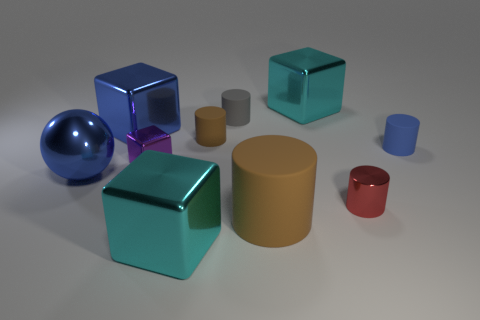Subtract 1 cylinders. How many cylinders are left? 4 Subtract all gray cylinders. How many cylinders are left? 4 Subtract all tiny gray matte cylinders. How many cylinders are left? 4 Subtract all green cylinders. Subtract all brown blocks. How many cylinders are left? 5 Subtract all blocks. How many objects are left? 6 Add 7 gray things. How many gray things are left? 8 Add 5 big cyan blocks. How many big cyan blocks exist? 7 Subtract 1 blue blocks. How many objects are left? 9 Subtract all purple shiny balls. Subtract all small matte cylinders. How many objects are left? 7 